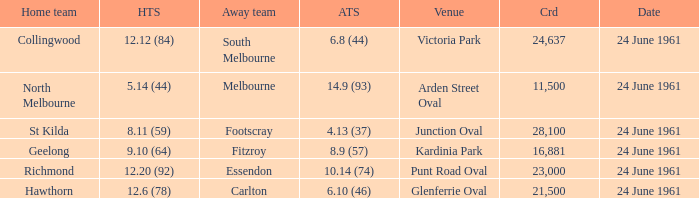What was the average crowd size of games held at Glenferrie Oval? 21500.0. 